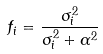<formula> <loc_0><loc_0><loc_500><loc_500>f _ { i } = \frac { \sigma _ { i } ^ { 2 } } { \sigma _ { i } ^ { 2 } + \alpha ^ { 2 } }</formula> 